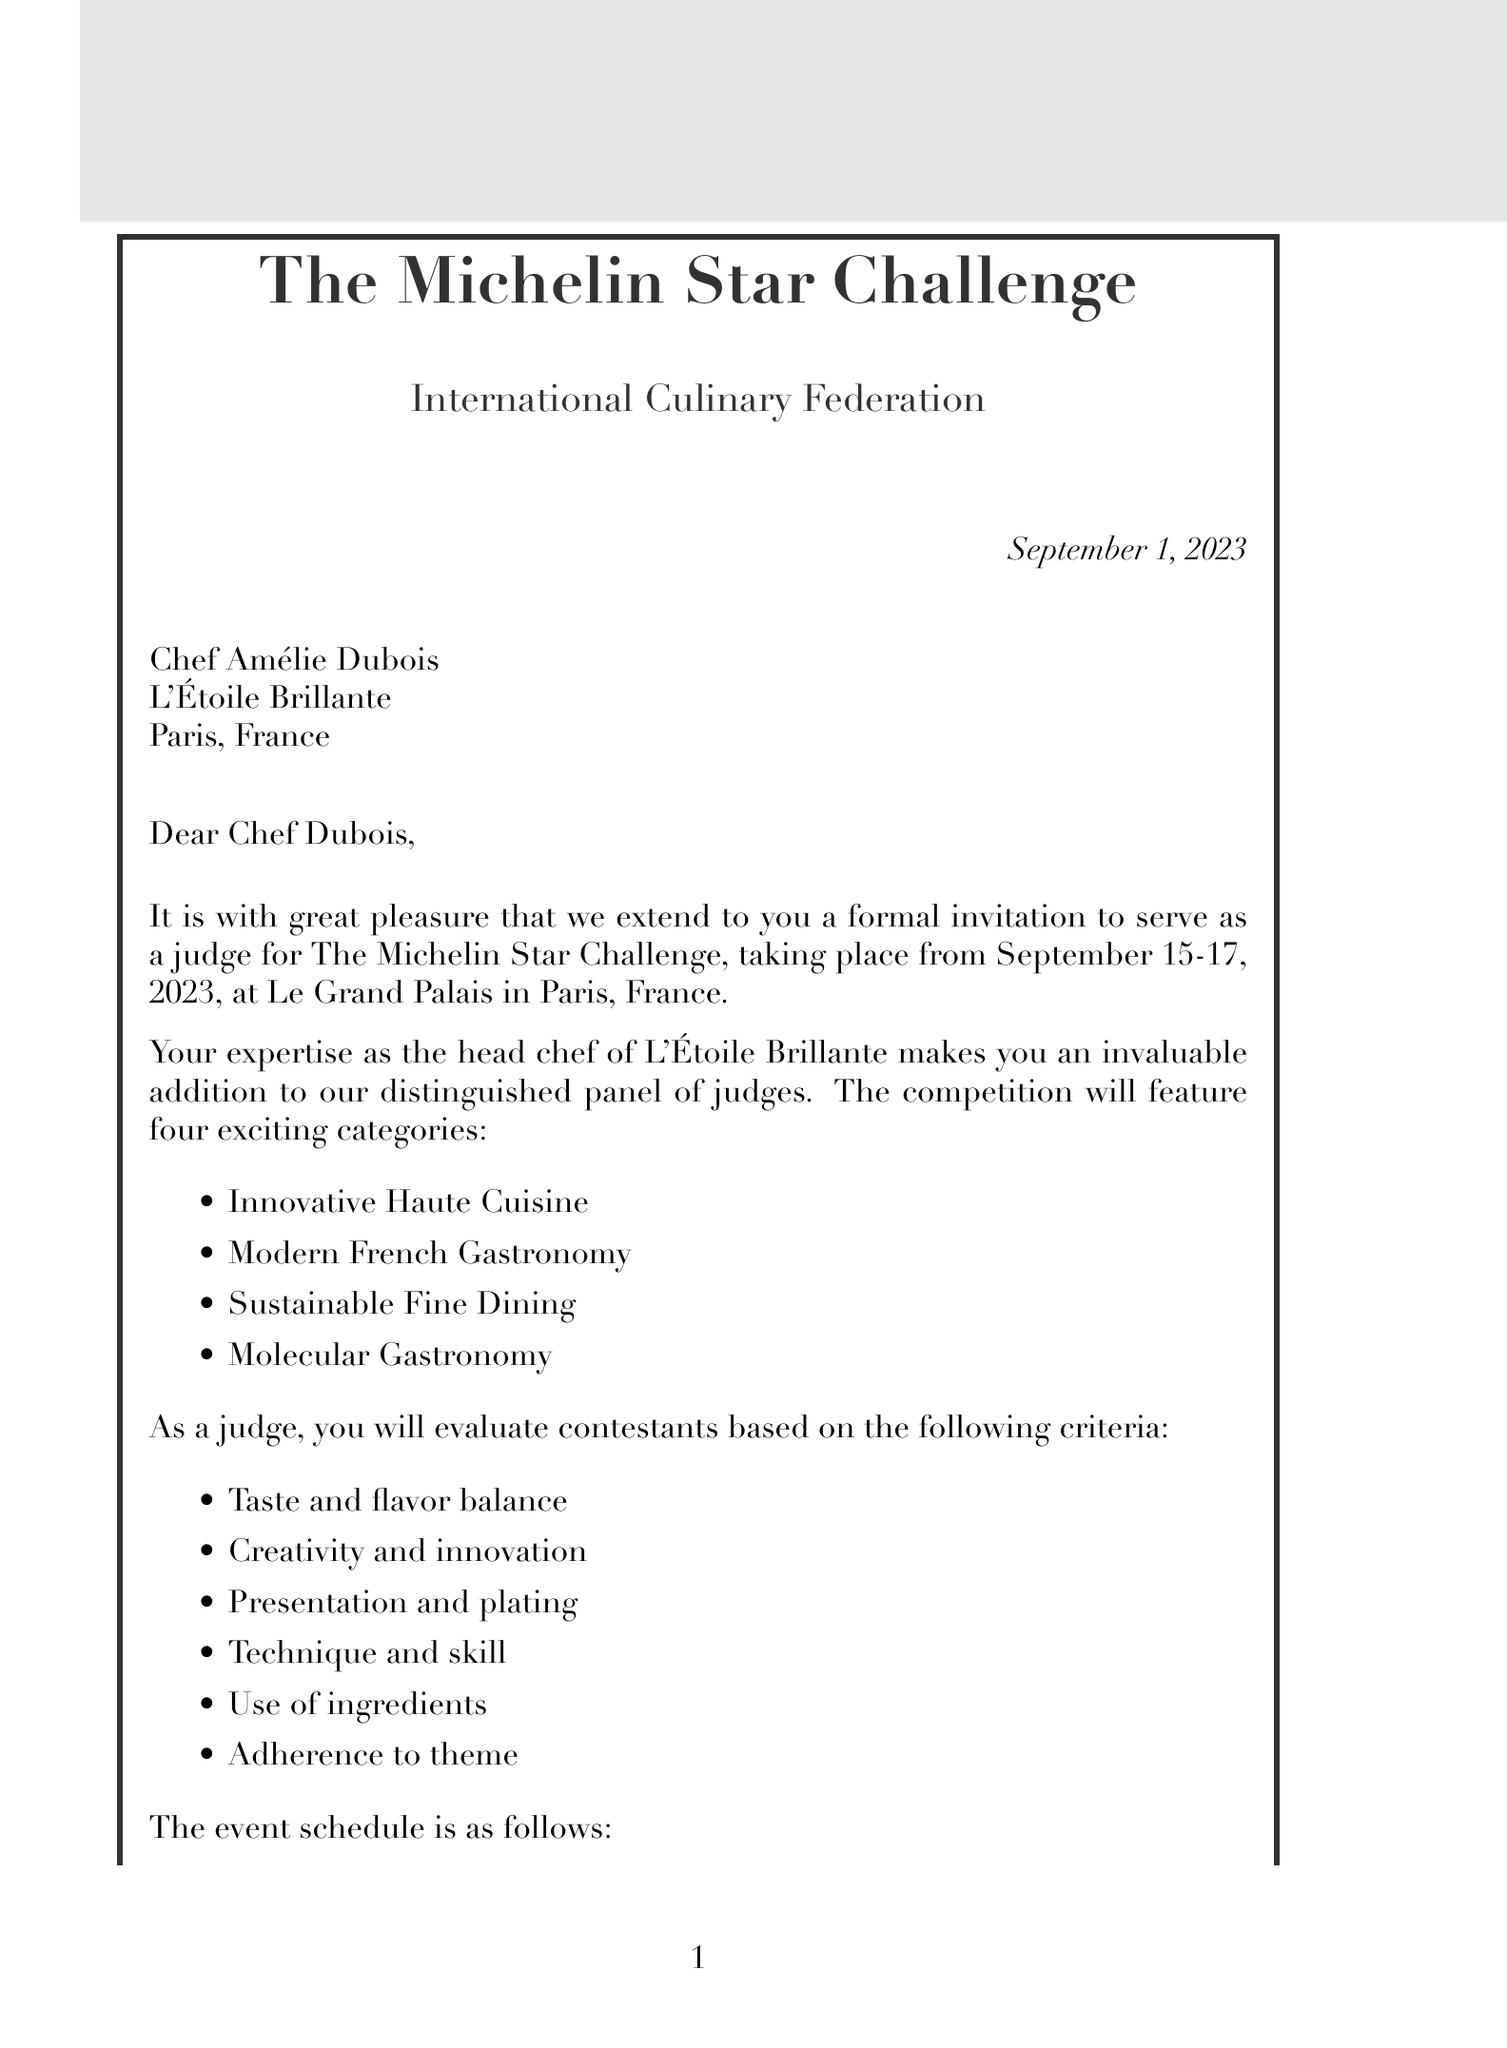What is the name of the event? The event is specifically titled "The Michelin Star Challenge."
Answer: The Michelin Star Challenge Who is the invitation recipient? The recipient of the invitation is explicitly mentioned as Chef Amélie Dubois.
Answer: Chef Amélie Dubois What are the dates of the event? The document specifies the event dates as September 15-17, 2023.
Answer: September 15-17, 2023 Which restaurant does Chef Amélie Dubois represent? The letter mentions that Chef Amélie Dubois is the head chef of L'Étoile Brillante.
Answer: L'Étoile Brillante What is one of the judging criteria listed? The criteria include "Taste and flavor balance," among others specified in the document.
Answer: Taste and flavor balance What is the dress code for the event? The document states that the required dress code is formal chef attire.
Answer: Formal chef attire What notable participants are mentioned? The document lists Alain Ducasse, Anne-Sophie Pic, and Gordon Ramsay as notable participants.
Answer: Alain Ducasse, Anne-Sophie Pic, Gordon Ramsay What is provided for travel arrangements? The letter notes that first-class train tickets or business class flights will be provided for the judges.
Answer: First-class train tickets or business class flights What accommodation is arranged for the judges? The document states that accommodation will be at The Ritz Paris.
Answer: The Ritz Paris 